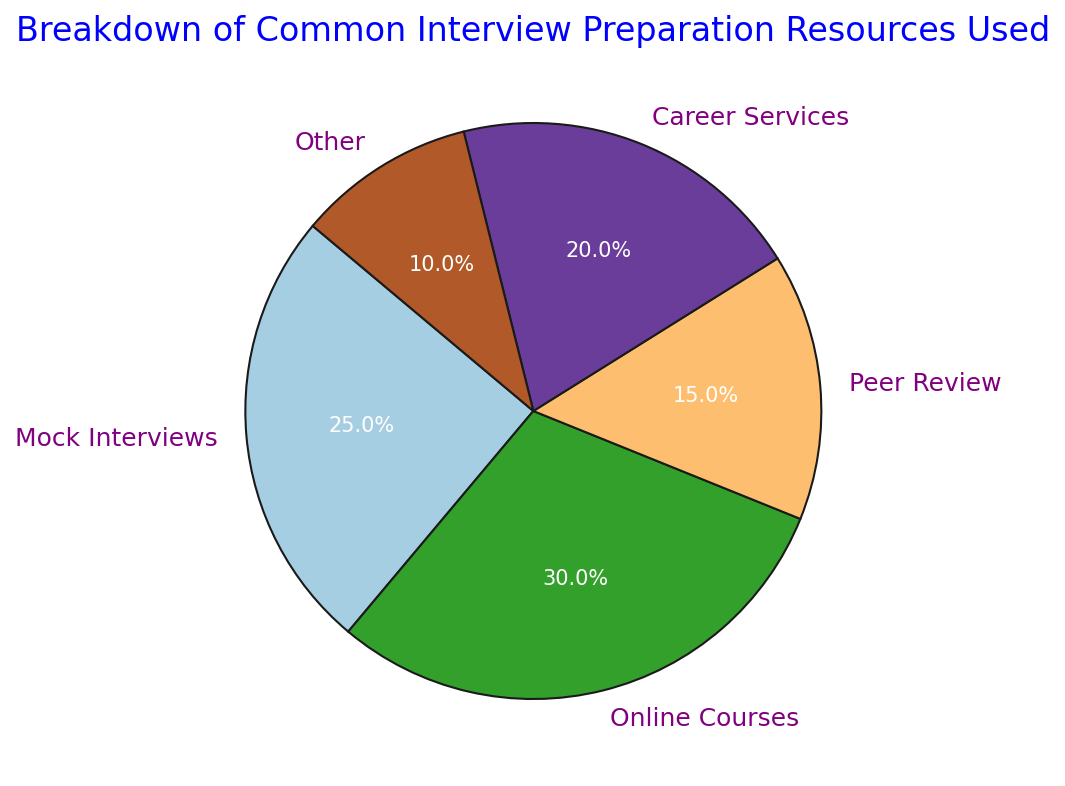What's the most commonly used interview preparation resource? To determine the most commonly used resource, we look for the segment of the pie chart with the largest percentage. From the chart, we see that Online Courses has the largest portion at 30%.
Answer: Online Courses What is the total percentage of people using Mock Interviews and Career Services? By adding the percentages of Mock Interviews (25%) and Career Services (20%), we get the total percentage. 25% + 20% = 45%.
Answer: 45% Which resource is used by the smallest percentage of people, and what is that percentage? We can identify the smallest segment in the pie chart, which is Other, with a percentage of 10%.
Answer: Other, 10% How much more popular are Online Courses compared to Peer Review? By subtracting the percentage of Peer Review (15%) from the percentage of Online Courses (30%), we find the difference. 30% - 15% = 15%.
Answer: 15% What is the combined percentage of career-related services (Career Services + Peer Review)? Adding the percentages of Career Services (20%) and Peer Review (15%), we find the combined total. 20% + 15% = 35%.
Answer: 35% What color represents the Career Services segment in the chart? From examining the pie chart, we see that Career Services is represented by a specific color, purple.
Answer: purple How do the percentages of Mock Interviews and Career Services compare? The percentage of Mock Interviews (25%) is higher than that of Career Services (20%).
Answer: Mock Interviews is higher Which segments of the pie chart are directly adjacent to the Other segment? The two segments directly adjacent to Other (10%) are Peer Review (15%) and Online Courses (30%).
Answer: Peer Review and Online Courses If Peer Review and Other were combined into a single category, what percentage of the total would it represent? Adding the percentages of Peer Review (15%) and Other (10%), the combined percentage is 15% + 10% = 25%.
Answer: 25%  By adding the percentages of Online Courses (30%) and Career Services (20%), these two segments together sum up to 30% + 20% = 50%.
Answer: Online Courses and Career Services 